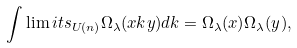Convert formula to latex. <formula><loc_0><loc_0><loc_500><loc_500>\int \lim i t s _ { U ( n ) } \Omega _ { \lambda } ( x k y ) d k = \Omega _ { \lambda } ( x ) \Omega _ { \lambda } ( y ) ,</formula> 